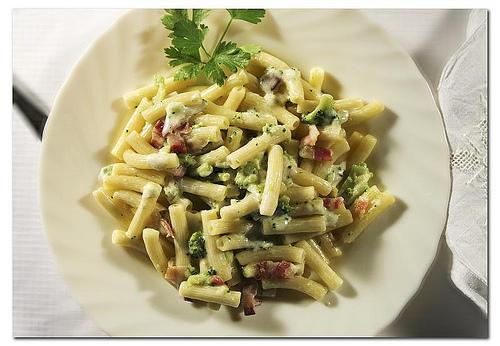Is this a carb heavy dish?
Answer briefly. Yes. What is the garnish?
Answer briefly. Parsley. Is the plate circle or square?
Quick response, please. Circle. 